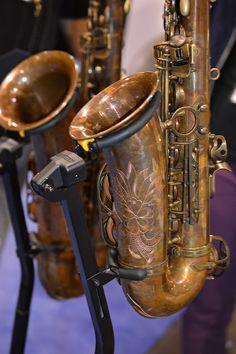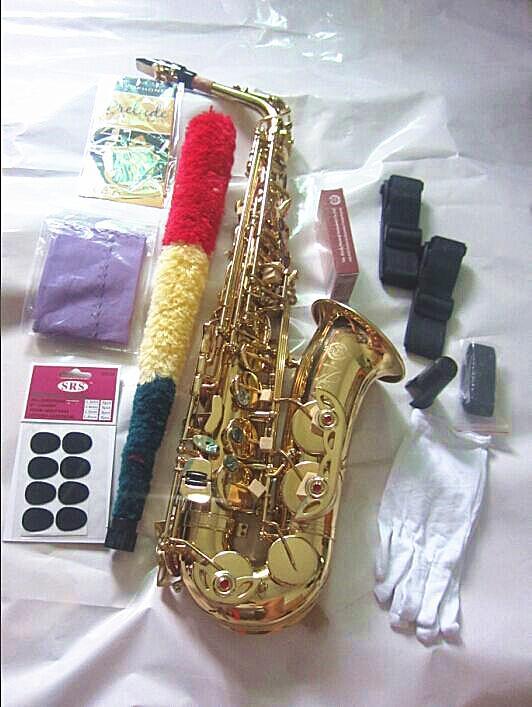The first image is the image on the left, the second image is the image on the right. Evaluate the accuracy of this statement regarding the images: "Both saxes are being positioned to face the same way.". Is it true? Answer yes or no. No. The first image is the image on the left, the second image is the image on the right. Evaluate the accuracy of this statement regarding the images: "An image includes a saxophone displayed on a black stand.". Is it true? Answer yes or no. Yes. 